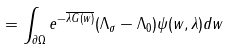<formula> <loc_0><loc_0><loc_500><loc_500>= \int _ { \partial \Omega } e ^ { - \overline { \lambda G ( w ) } } ( \Lambda _ { \sigma } - \Lambda _ { 0 } ) \psi ( w , \lambda ) d w</formula> 